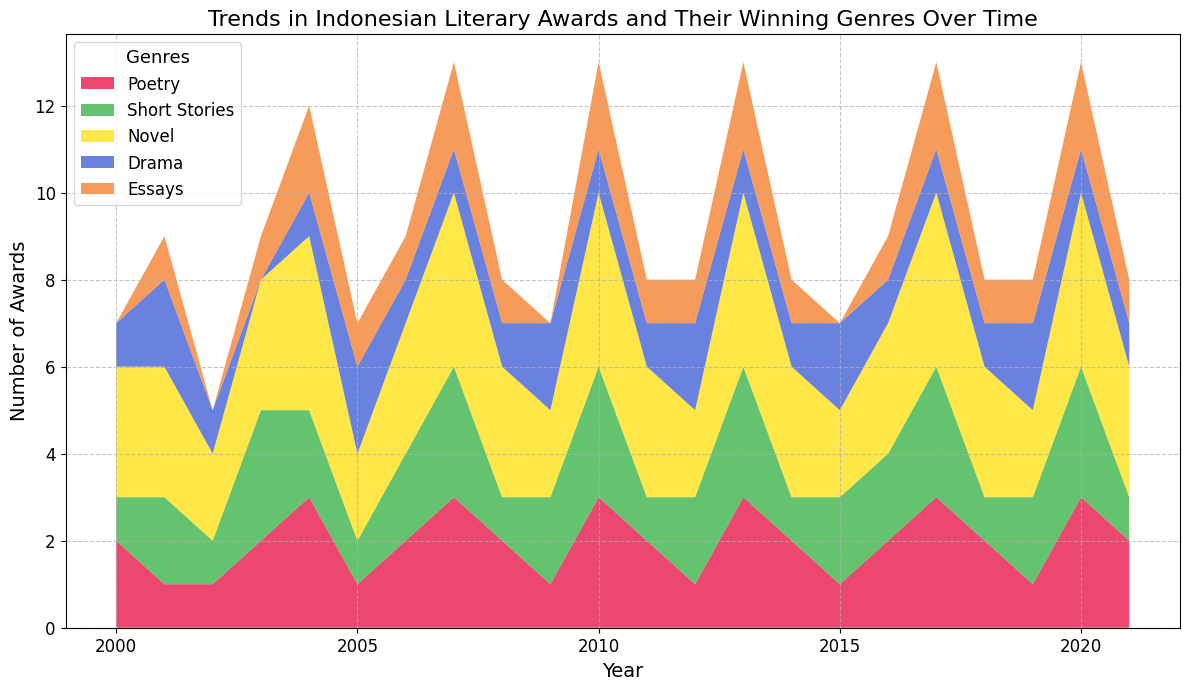Which genre has the most awards in the year 2000? From the figure, look for the height of each color stack (representing genres) at the year 2000. The tallest stack, which represents "Novel," has the most awards.
Answer: Novel By how much did the number of poetry awards increase from 2001 to 2004? Identify the counts for poetry in 2001 and 2004 from the figure. In 2001, there is 1 award for poetry, and in 2004, there are 3 awards. Subtract the counts: 3 - 1.
Answer: 2 Which genre shows a general increase in awards over the entire period? Observe each genre's trend over time. "Novel" consistently shows an upward trend in awards from the beginning to the end of the period.
Answer: Novel In which year was the total number of awards given the highest? Sum the awards for all genres each year by looking at the peak heights. The highest point is reached in 2007, 2010, 2013, 2017, and 2020 where the sum of all heights is the largest.
Answer: 2007, 2010, 2013, 2017, 2020 What is the average number of short story awards given from 2015 to 2020? From the figure, count the short story awards for each year from 2015 to 2020. These are: 2015 - 2, 2016 - 2, 2017 - 3, 2018 - 1, 2019 - 2, 2020 - 3. Sum them up and divide by the number of years: (2+2+3+1+2+3)/6.
Answer: 2.17 Which genre has the least variation in the number of awards throughout the years? Observe the area representing each genre for constancy. Essays appear to have the least variation as the area representing them remains relatively small and consistent.
Answer: Essays From which year did the drama awards start becoming more frequent compared to before? Identify the visual pattern for drama. It increases notably from around 2001 onwards. Before 2000 and 2001, the drama genre had fewer or no awards.
Answer: 2001 How many years did poetry receive more awards than short stories? Compare the height of poetry and short stories stacks for each year. Poetry received more awards in these years: 2000, 2014, and 2021. Count these years.
Answer: 3 What is the overall trend in the number of novel awards from 2015 to 2021? Observe the stacked plot area for the novel genre from 2015 to 2021. The trend remains constant and high throughout these years.
Answer: Constant Comparing 2005 and 2010, which year had more awards given to dramas and by how much? Identify the heights of the drama stack for 2005 and 2010. Drama received 2 awards in 2005 and 1 award in 2010. Subtract the values: 2 - 1.
Answer: 2005, 1 